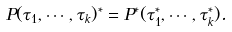<formula> <loc_0><loc_0><loc_500><loc_500>P ( \tau _ { 1 } , \cdots , \tau _ { k } ) ^ { * } = P ^ { * } ( \tau _ { 1 } ^ { * } , \cdots , \tau _ { k } ^ { * } ) .</formula> 